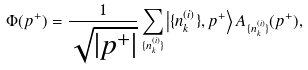Convert formula to latex. <formula><loc_0><loc_0><loc_500><loc_500>\Phi ( p ^ { + } ) = \frac { 1 } { \sqrt { | p ^ { + } | } } \sum _ { \{ n ^ { ( i ) } _ { k } \} } \left | \{ n ^ { ( i ) } _ { k } \} , p ^ { + } \right \rangle A _ { \{ n ^ { ( i ) } _ { k } \} } ( p ^ { + } ) ,</formula> 